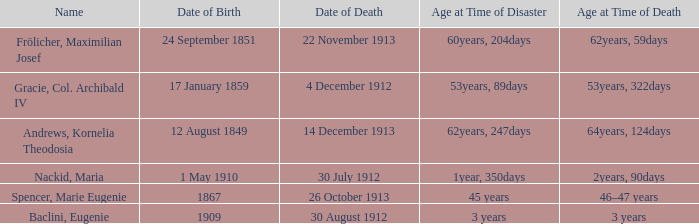When did the person born 24 September 1851 pass away? 22 November 1913. 